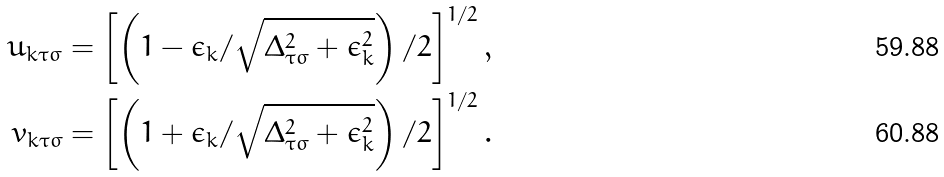<formula> <loc_0><loc_0><loc_500><loc_500>u _ { k \tau \sigma } = \left [ \left ( 1 - \epsilon _ { k } / \sqrt { \Delta ^ { 2 } _ { \tau \sigma } + \epsilon ^ { 2 } _ { k } } \right ) / 2 \right ] ^ { 1 / 2 } , \\ v _ { k \tau \sigma } = \left [ \left ( 1 + \epsilon _ { k } / \sqrt { \Delta ^ { 2 } _ { \tau \sigma } + \epsilon ^ { 2 } _ { k } } \right ) / 2 \right ] ^ { 1 / 2 } .</formula> 